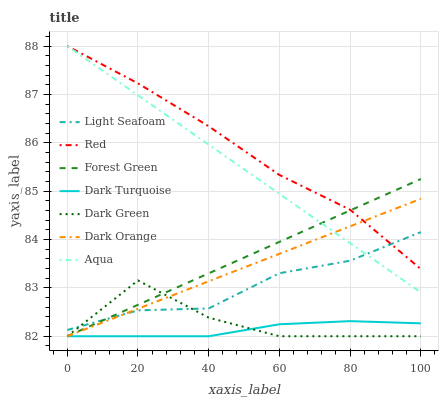Does Dark Turquoise have the minimum area under the curve?
Answer yes or no. Yes. Does Red have the maximum area under the curve?
Answer yes or no. Yes. Does Aqua have the minimum area under the curve?
Answer yes or no. No. Does Aqua have the maximum area under the curve?
Answer yes or no. No. Is Forest Green the smoothest?
Answer yes or no. Yes. Is Dark Green the roughest?
Answer yes or no. Yes. Is Dark Turquoise the smoothest?
Answer yes or no. No. Is Dark Turquoise the roughest?
Answer yes or no. No. Does Dark Orange have the lowest value?
Answer yes or no. Yes. Does Aqua have the lowest value?
Answer yes or no. No. Does Red have the highest value?
Answer yes or no. Yes. Does Dark Turquoise have the highest value?
Answer yes or no. No. Is Dark Turquoise less than Aqua?
Answer yes or no. Yes. Is Light Seafoam greater than Dark Turquoise?
Answer yes or no. Yes. Does Dark Orange intersect Red?
Answer yes or no. Yes. Is Dark Orange less than Red?
Answer yes or no. No. Is Dark Orange greater than Red?
Answer yes or no. No. Does Dark Turquoise intersect Aqua?
Answer yes or no. No. 